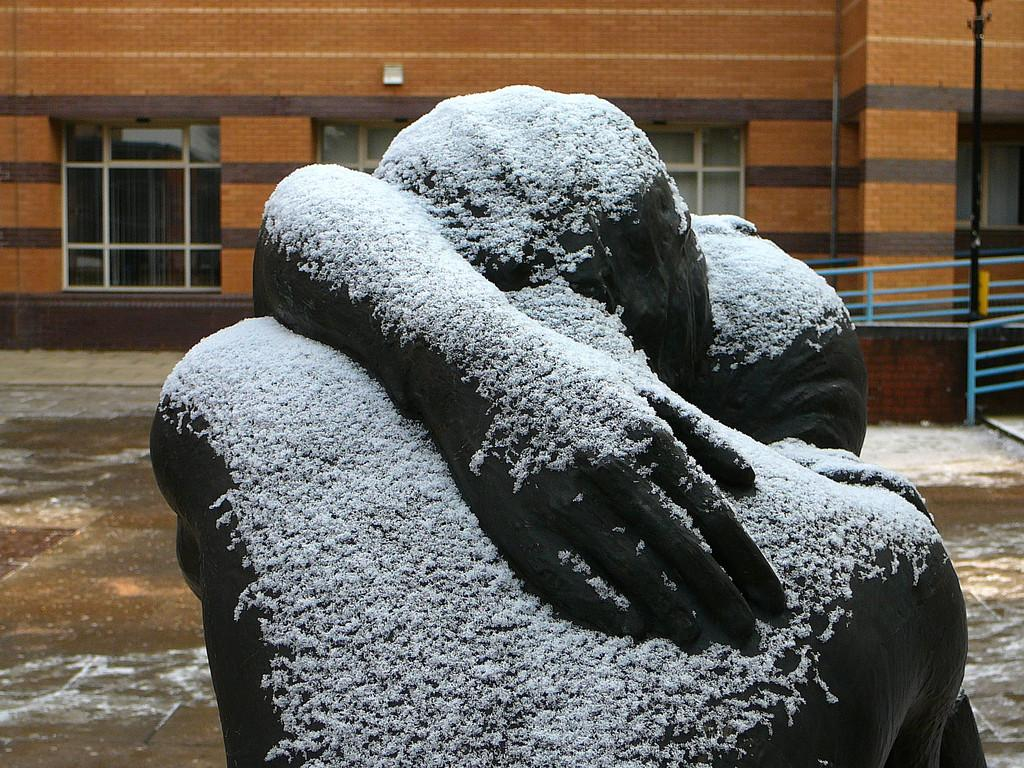What is the main subject of the image? There is a sculpture in the image. What can be seen in the background of the image? There is a building in the background of the image. What feature of the building is mentioned in the facts? The building has windows. What is located on the left side of the image? There is fencing on the left side of the image. How does the worm interact with the sculpture in the image? There is no worm present in the image, so it cannot interact with the sculpture. 